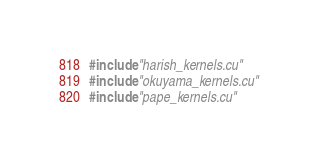Convert code to text. <code><loc_0><loc_0><loc_500><loc_500><_Cuda_>#include "harish_kernels.cu"
#include "okuyama_kernels.cu"
#include "pape_kernels.cu"

</code> 